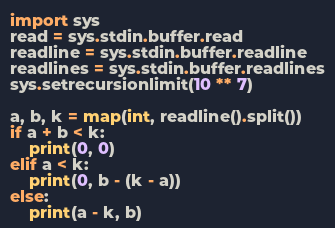<code> <loc_0><loc_0><loc_500><loc_500><_Python_>import sys
read = sys.stdin.buffer.read
readline = sys.stdin.buffer.readline
readlines = sys.stdin.buffer.readlines
sys.setrecursionlimit(10 ** 7)

a, b, k = map(int, readline().split())
if a + b < k:
    print(0, 0)
elif a < k:
    print(0, b - (k - a))
else:
    print(a - k, b)
</code> 